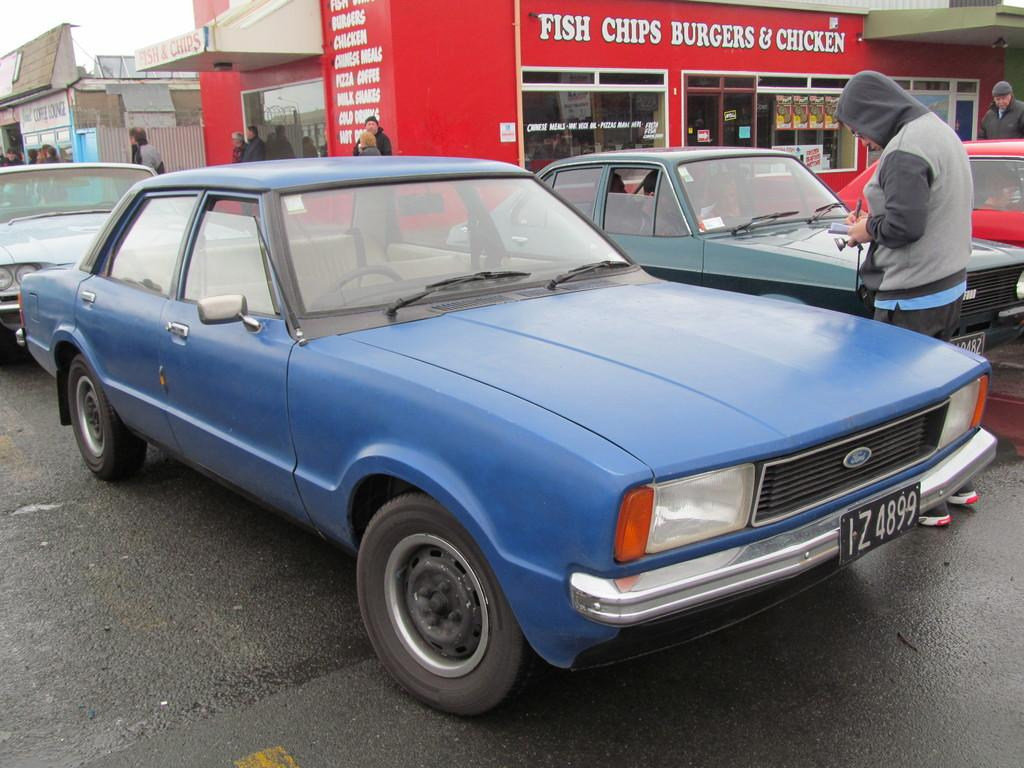<image>
Relay a brief, clear account of the picture shown. Older car with license plate IZ4899 that is parked at a fast food restaurant that sells Fish, Chips, Burgers & Chicken. 